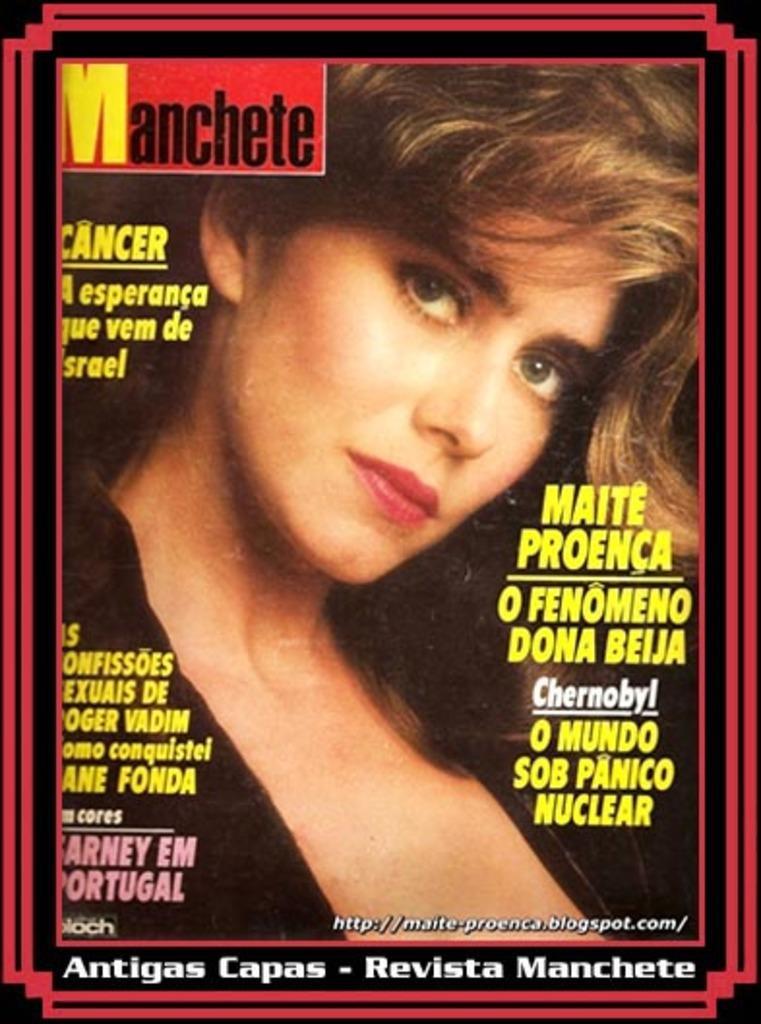How would you summarize this image in a sentence or two? In this picture, it looks like a poster of a woman. On the poster, it is written something. 